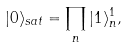Convert formula to latex. <formula><loc_0><loc_0><loc_500><loc_500>| 0 \rangle _ { s a t } = \prod _ { n } | 1 \rangle ^ { 1 } _ { n } ,</formula> 